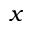Convert formula to latex. <formula><loc_0><loc_0><loc_500><loc_500>x</formula> 